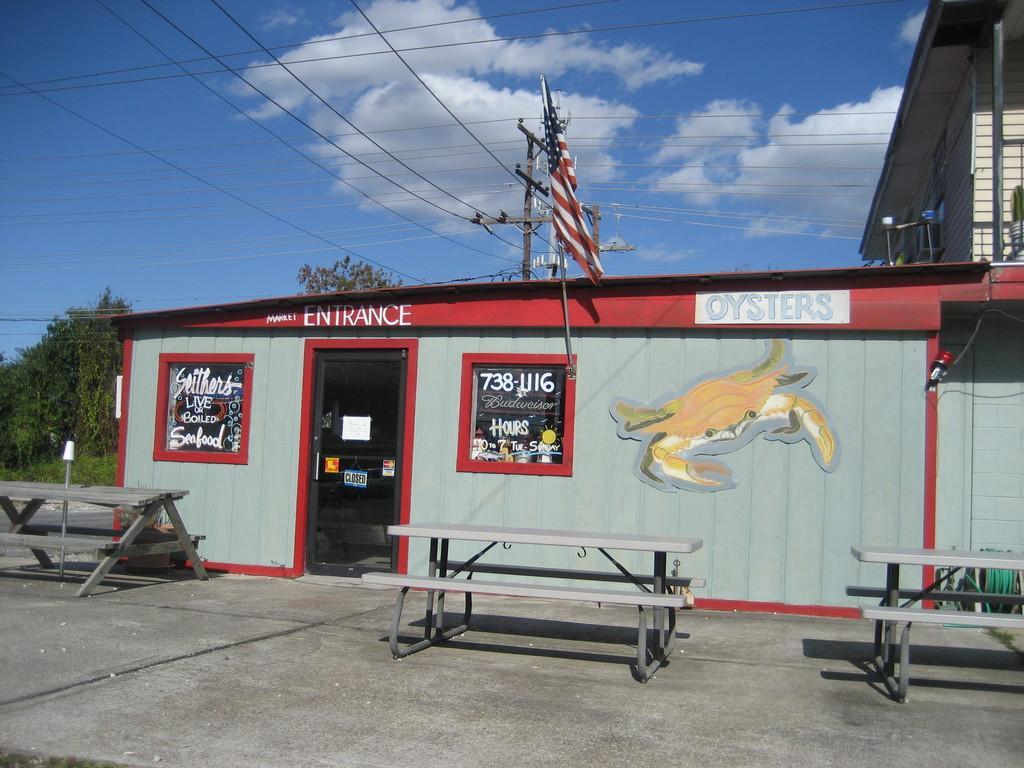Could you give a brief overview of what you see in this image? In this picture, there is a building made up of wood. Towards the left, there is a door and windows. On the house, there is some text and pictures. Before it, there are three benches. At the bottom, there is a road. On the top, there is a flag and wires. In the background there are trees and sky with clouds. 